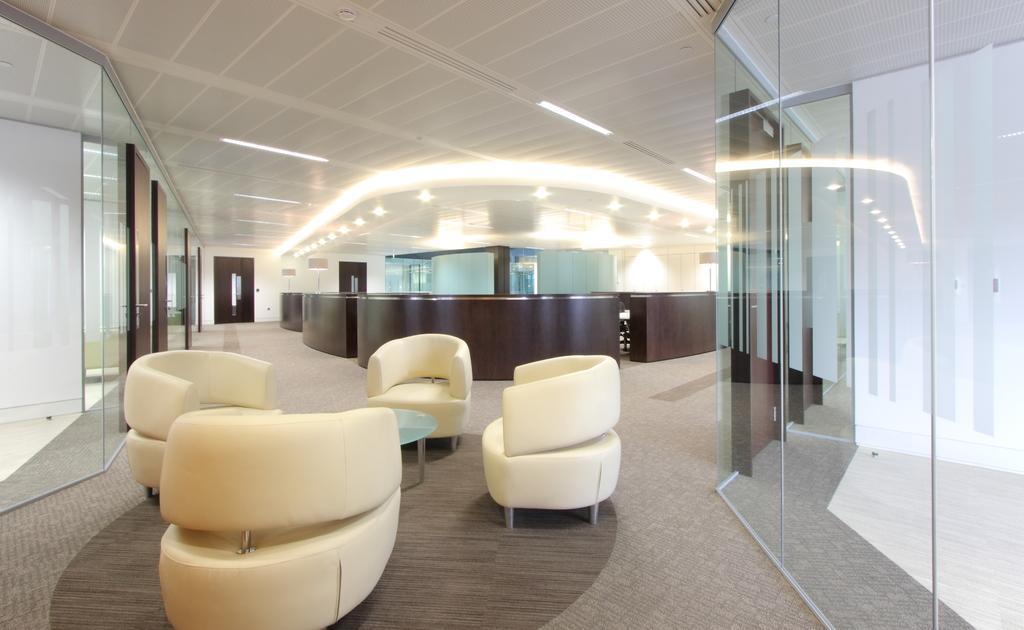How would you summarize this image in a sentence or two? In this picture I can observe white color chairs and a table. On the right side I can observe glass. In the background there is a brown color desk and I can observe some lights in the ceiling. 